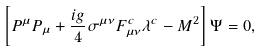<formula> <loc_0><loc_0><loc_500><loc_500>\left [ P ^ { \mu } P _ { \mu } + \frac { i g } { 4 } \sigma ^ { \mu \nu } F ^ { c } _ { \mu \nu } \lambda ^ { c } - M ^ { 2 } \right ] \Psi = 0 ,</formula> 